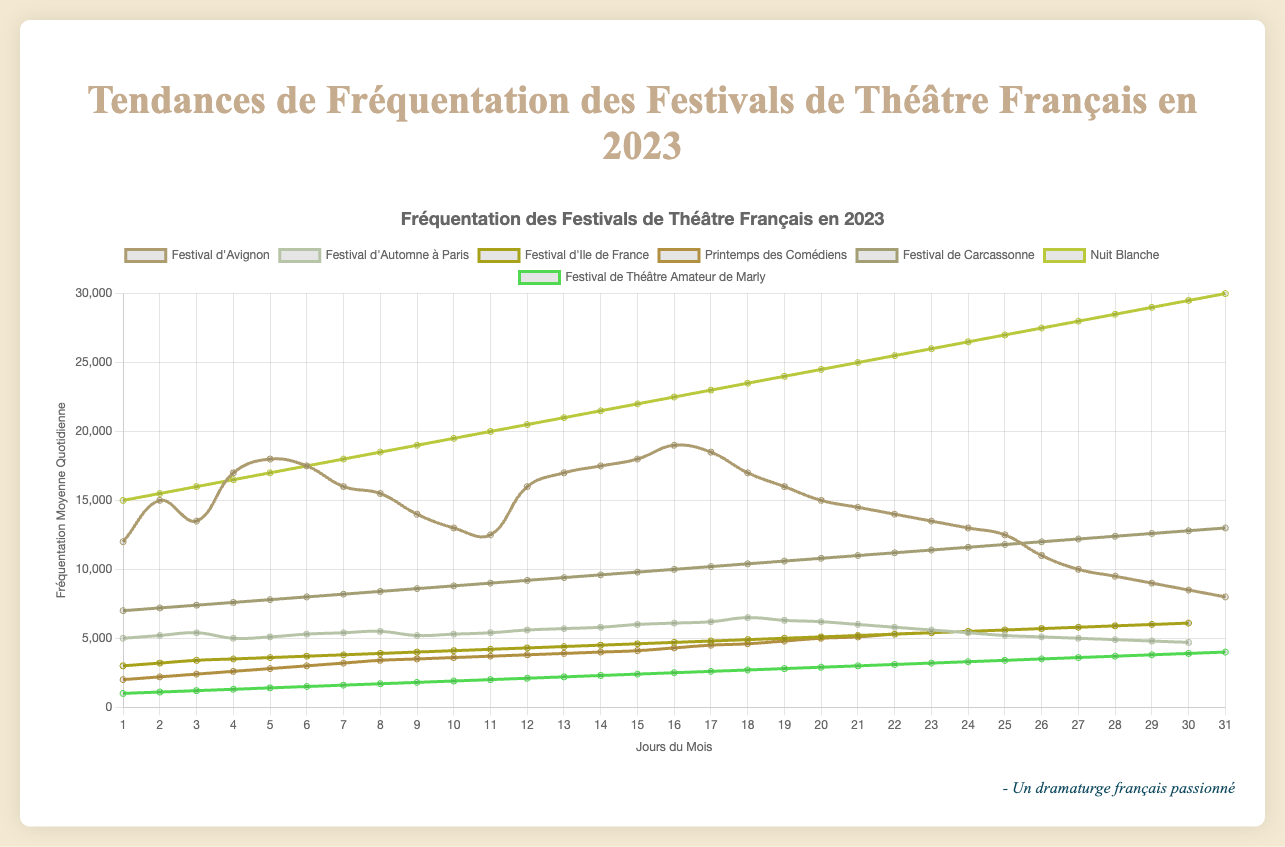What festivals show a significant increase in attendance throughout the month? From the figure, look for datasets (lines) that have a clear upward trend as the days progress. Both "Nuit Blanche" and "Festival de Carcassonne" show significant increases in attendance throughout their respective months.
Answer: "Nuit Blanche" and "Festival de Carcassonne" Between "Festival d'Avignon" and "Festival d'Automne à Paris", which one has a higher peak attendance? Look at the highest points (peaks) on the respective lines of "Festival d'Avignon" and "Festival d'Automne à Paris". "Festival d'Avignon" peaks at 19,000 attendees, whereas "Festival d'Automne à Paris" peaks at around 6,500 attendees.
Answer: "Festival d'Avignon" What is the average of the peak attendances of the "Festival d’Ile de France" and "Printemps des Comédiens"? Determine the highest points of each festival: "Festival d’Ile de France" peaks at 6,100 and "Printemps des Comédiens" peaks at 6,100 as well. Compute the average of these numbers: (6100 + 6100) / 2 = 6100.
Answer: 6100 How does the lowest daily attendance of "Festival d'Avignon" compare to the highest daily attendance of "Festival de Théâtre Amateur de Marly"? Identify the lowest point on the "Festival d'Avignon" line, which is 8,000 attendees, then find the highest point on the "Festival de Théâtre Amateur de Marly" line, which is 4,000 attendees. Compare these values, 8,000 is more than 4,000.
Answer: "Festival d'Avignon" has higher minimum attendance Which festival has the steepest increase in attendance? Identify the festival with the most vertical-looking line. "Nuit Blanche" shows a rapid increase in attendance from 15,000 to 30,000, indicating the steepest increase.
Answer: "Nuit Blanche" Are there any festivals that show a decline in attendance as the days progress? Look for lines that trend downward. "Festival d’Avignon" shows a noticeable decline in attendance from around the middle of the month.
Answer: "Festival d’Avignon" What difference in attendance can be observed between day 15 and day 30 for "Festival de Carcassonne"? Locate day 15 and day 30 on the "Festival de Carcassonne" line, which are 10,000 and 13,000 respectively. The difference is 13,000 - 10,000 = 3,000.
Answer: 3,000 Which festival maintains the most consistent daily attendance? Look for the line that shows the least variation. "Festival d'Automne à Paris" has the flattest curve, indicating the most consistent attendance.
Answer: "Festival d'Automne à Paris" What is the combined attendance of "Printemps des Comédiens" and "Festival de Carcassonne" on their last days? Sum the attendance of both festivals on day 31: "Printemps des Comédiens" has 6,100 and "Festival de Carcassonne" has 13,000. Combined, it is 6,100 + 13,000 = 19,100.
Answer: 19,100 